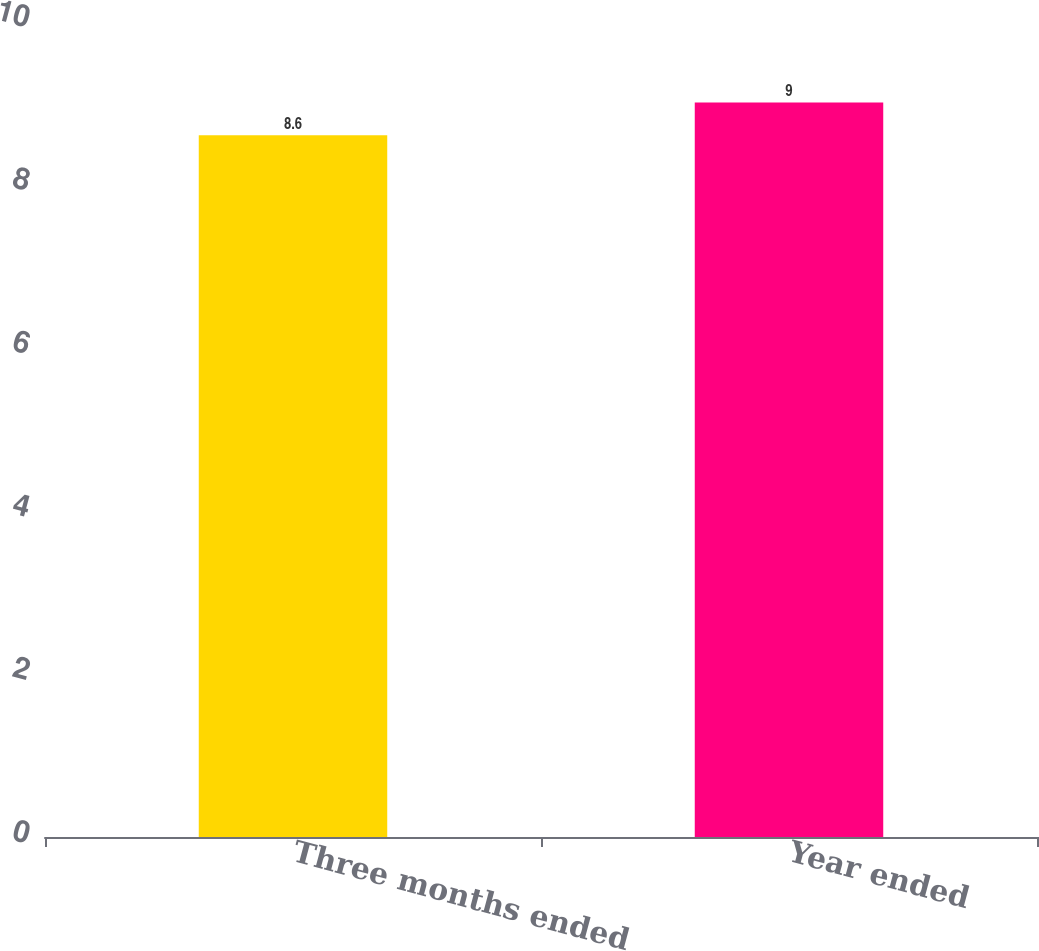<chart> <loc_0><loc_0><loc_500><loc_500><bar_chart><fcel>Three months ended<fcel>Year ended<nl><fcel>8.6<fcel>9<nl></chart> 